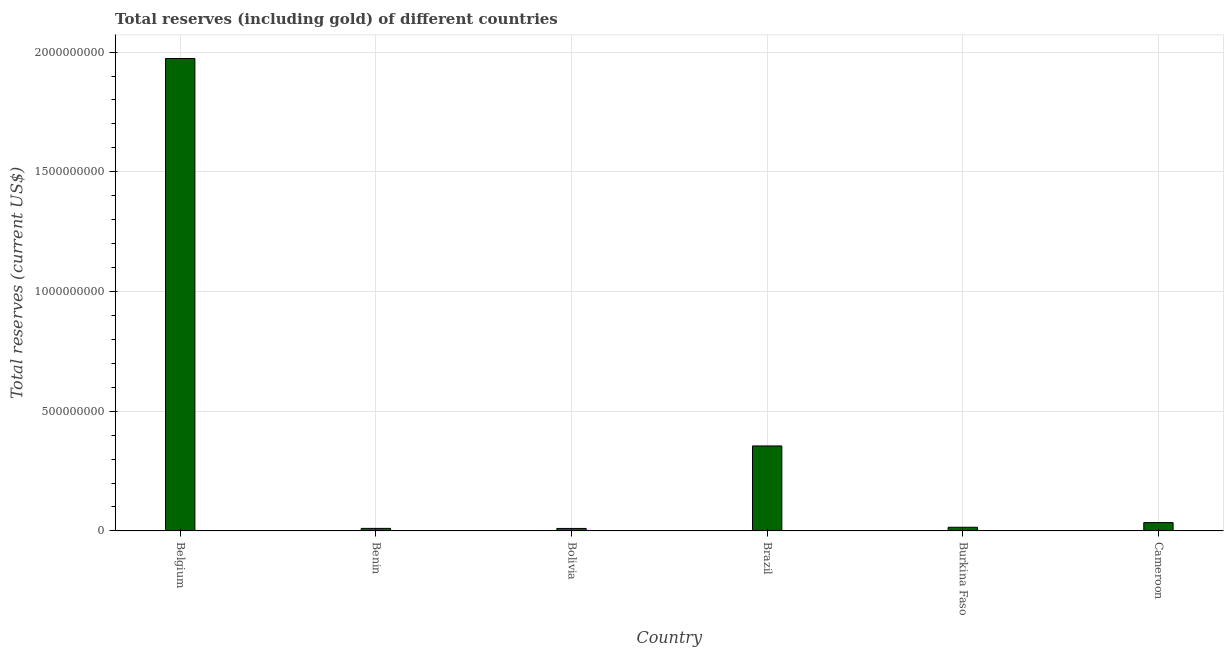Does the graph contain any zero values?
Provide a succinct answer. No. What is the title of the graph?
Offer a very short reply. Total reserves (including gold) of different countries. What is the label or title of the Y-axis?
Offer a very short reply. Total reserves (current US$). What is the total reserves (including gold) in Brazil?
Your answer should be compact. 3.55e+08. Across all countries, what is the maximum total reserves (including gold)?
Ensure brevity in your answer.  1.97e+09. Across all countries, what is the minimum total reserves (including gold)?
Make the answer very short. 1.04e+07. In which country was the total reserves (including gold) maximum?
Provide a short and direct response. Belgium. What is the sum of the total reserves (including gold)?
Make the answer very short. 2.40e+09. What is the difference between the total reserves (including gold) in Brazil and Burkina Faso?
Give a very brief answer. 3.40e+08. What is the average total reserves (including gold) per country?
Provide a succinct answer. 4.00e+08. What is the median total reserves (including gold)?
Your answer should be very brief. 2.51e+07. What is the ratio of the total reserves (including gold) in Benin to that in Bolivia?
Ensure brevity in your answer.  1.03. Is the total reserves (including gold) in Benin less than that in Brazil?
Offer a terse response. Yes. Is the difference between the total reserves (including gold) in Brazil and Cameroon greater than the difference between any two countries?
Your response must be concise. No. What is the difference between the highest and the second highest total reserves (including gold)?
Keep it short and to the point. 1.62e+09. What is the difference between the highest and the lowest total reserves (including gold)?
Ensure brevity in your answer.  1.96e+09. In how many countries, is the total reserves (including gold) greater than the average total reserves (including gold) taken over all countries?
Your response must be concise. 1. Are all the bars in the graph horizontal?
Offer a terse response. No. How many countries are there in the graph?
Ensure brevity in your answer.  6. Are the values on the major ticks of Y-axis written in scientific E-notation?
Make the answer very short. No. What is the Total reserves (current US$) of Belgium?
Offer a terse response. 1.97e+09. What is the Total reserves (current US$) of Benin?
Your response must be concise. 1.07e+07. What is the Total reserves (current US$) of Bolivia?
Make the answer very short. 1.04e+07. What is the Total reserves (current US$) in Brazil?
Keep it short and to the point. 3.55e+08. What is the Total reserves (current US$) of Burkina Faso?
Your answer should be very brief. 1.54e+07. What is the Total reserves (current US$) in Cameroon?
Give a very brief answer. 3.49e+07. What is the difference between the Total reserves (current US$) in Belgium and Benin?
Keep it short and to the point. 1.96e+09. What is the difference between the Total reserves (current US$) in Belgium and Bolivia?
Offer a very short reply. 1.96e+09. What is the difference between the Total reserves (current US$) in Belgium and Brazil?
Your response must be concise. 1.62e+09. What is the difference between the Total reserves (current US$) in Belgium and Burkina Faso?
Offer a very short reply. 1.96e+09. What is the difference between the Total reserves (current US$) in Belgium and Cameroon?
Your answer should be very brief. 1.94e+09. What is the difference between the Total reserves (current US$) in Benin and Bolivia?
Your response must be concise. 2.95e+05. What is the difference between the Total reserves (current US$) in Benin and Brazil?
Your answer should be compact. -3.44e+08. What is the difference between the Total reserves (current US$) in Benin and Burkina Faso?
Your answer should be compact. -4.70e+06. What is the difference between the Total reserves (current US$) in Benin and Cameroon?
Your answer should be very brief. -2.42e+07. What is the difference between the Total reserves (current US$) in Bolivia and Brazil?
Your answer should be very brief. -3.45e+08. What is the difference between the Total reserves (current US$) in Bolivia and Burkina Faso?
Give a very brief answer. -5.00e+06. What is the difference between the Total reserves (current US$) in Bolivia and Cameroon?
Your response must be concise. -2.45e+07. What is the difference between the Total reserves (current US$) in Brazil and Burkina Faso?
Give a very brief answer. 3.40e+08. What is the difference between the Total reserves (current US$) in Brazil and Cameroon?
Your response must be concise. 3.20e+08. What is the difference between the Total reserves (current US$) in Burkina Faso and Cameroon?
Offer a very short reply. -1.95e+07. What is the ratio of the Total reserves (current US$) in Belgium to that in Benin?
Your answer should be very brief. 184.43. What is the ratio of the Total reserves (current US$) in Belgium to that in Bolivia?
Your answer should be very brief. 189.66. What is the ratio of the Total reserves (current US$) in Belgium to that in Brazil?
Provide a short and direct response. 5.56. What is the ratio of the Total reserves (current US$) in Belgium to that in Burkina Faso?
Provide a succinct answer. 128.14. What is the ratio of the Total reserves (current US$) in Belgium to that in Cameroon?
Make the answer very short. 56.58. What is the ratio of the Total reserves (current US$) in Benin to that in Bolivia?
Your response must be concise. 1.03. What is the ratio of the Total reserves (current US$) in Benin to that in Burkina Faso?
Offer a terse response. 0.69. What is the ratio of the Total reserves (current US$) in Benin to that in Cameroon?
Provide a succinct answer. 0.31. What is the ratio of the Total reserves (current US$) in Bolivia to that in Brazil?
Ensure brevity in your answer.  0.03. What is the ratio of the Total reserves (current US$) in Bolivia to that in Burkina Faso?
Ensure brevity in your answer.  0.68. What is the ratio of the Total reserves (current US$) in Bolivia to that in Cameroon?
Provide a short and direct response. 0.3. What is the ratio of the Total reserves (current US$) in Brazil to that in Burkina Faso?
Give a very brief answer. 23.05. What is the ratio of the Total reserves (current US$) in Brazil to that in Cameroon?
Keep it short and to the point. 10.18. What is the ratio of the Total reserves (current US$) in Burkina Faso to that in Cameroon?
Give a very brief answer. 0.44. 